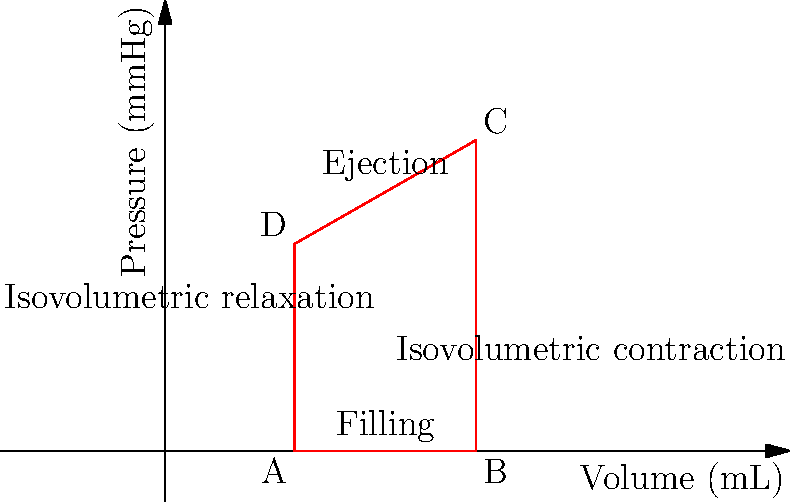As a patient with regular cardiology care, you're shown this pressure-volume loop graph representing one cardiac cycle. What is the stroke volume (in mL) based on the information provided in the graph? To determine the stroke volume from the pressure-volume loop graph, we need to follow these steps:

1. Understand what stroke volume represents:
   Stroke volume is the amount of blood ejected from the left ventricle during one contraction.

2. Identify the relevant points on the graph:
   - Point A: End-diastolic volume (EDV)
   - Point B: End-systolic volume (ESV)

3. Calculate the difference between EDV and ESV:
   - EDV (Point B) = 120 mL
   - ESV (Point A) = 50 mL

4. Apply the formula for stroke volume:
   $$ \text{Stroke Volume} = \text{EDV} - \text{ESV} $$

5. Substitute the values:
   $$ \text{Stroke Volume} = 120 \text{ mL} - 50 \text{ mL} = 70 \text{ mL} $$

Therefore, the stroke volume based on the information provided in the graph is 70 mL.
Answer: 70 mL 